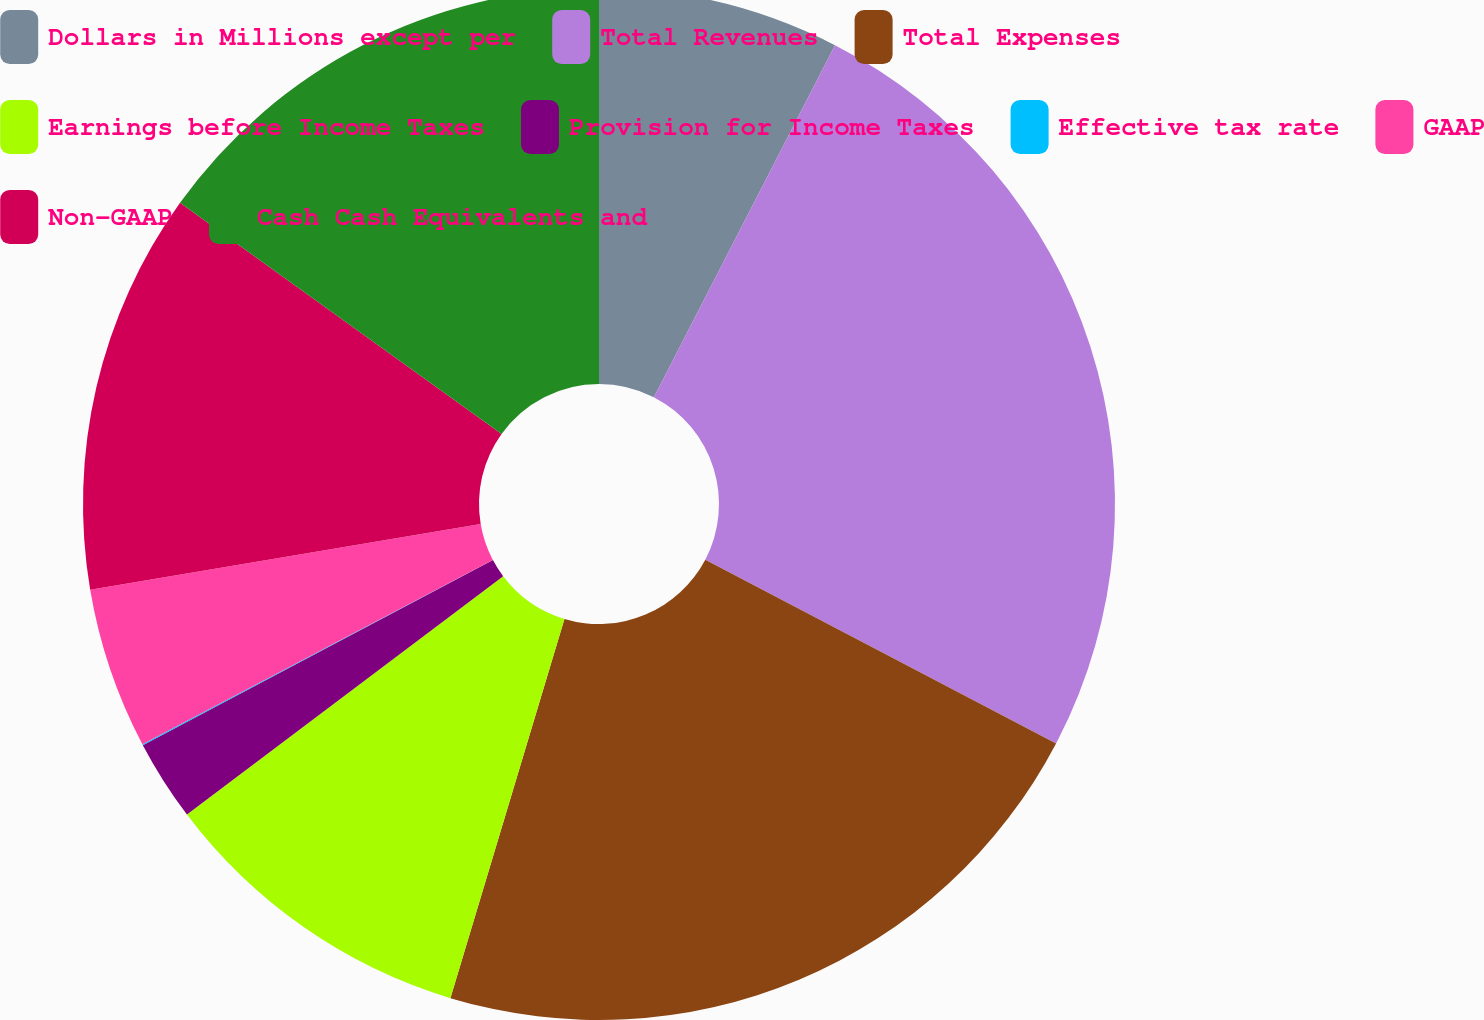<chart> <loc_0><loc_0><loc_500><loc_500><pie_chart><fcel>Dollars in Millions except per<fcel>Total Revenues<fcel>Total Expenses<fcel>Earnings before Income Taxes<fcel>Provision for Income Taxes<fcel>Effective tax rate<fcel>GAAP<fcel>Non-GAAP<fcel>Cash Cash Equivalents and<nl><fcel>7.56%<fcel>25.12%<fcel>21.97%<fcel>10.07%<fcel>2.54%<fcel>0.03%<fcel>5.05%<fcel>12.58%<fcel>15.08%<nl></chart> 